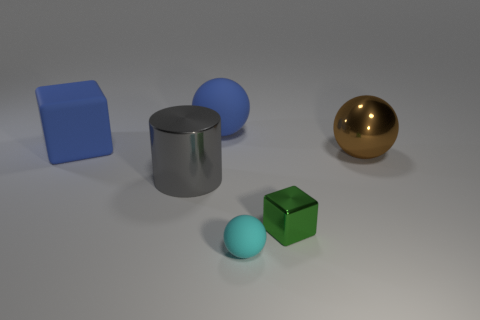What material is the tiny object that is behind the sphere that is in front of the large brown metallic thing made of?
Give a very brief answer. Metal. Are there an equal number of big brown things that are to the left of the large brown metallic object and blue matte blocks?
Your answer should be very brief. No. Are there any other things that have the same material as the big gray thing?
Make the answer very short. Yes. Do the rubber sphere that is behind the large brown ball and the large metallic thing on the right side of the tiny ball have the same color?
Your answer should be compact. No. How many objects are both left of the green block and in front of the gray cylinder?
Ensure brevity in your answer.  1. What number of other objects are the same shape as the big gray metallic thing?
Ensure brevity in your answer.  0. Is the number of tiny cyan rubber things that are behind the tiny cyan thing greater than the number of blue cylinders?
Provide a short and direct response. No. There is a large sphere on the left side of the green metallic block; what color is it?
Make the answer very short. Blue. What size is the ball that is the same color as the large block?
Provide a succinct answer. Large. How many matte objects are either blue balls or cyan balls?
Keep it short and to the point. 2. 